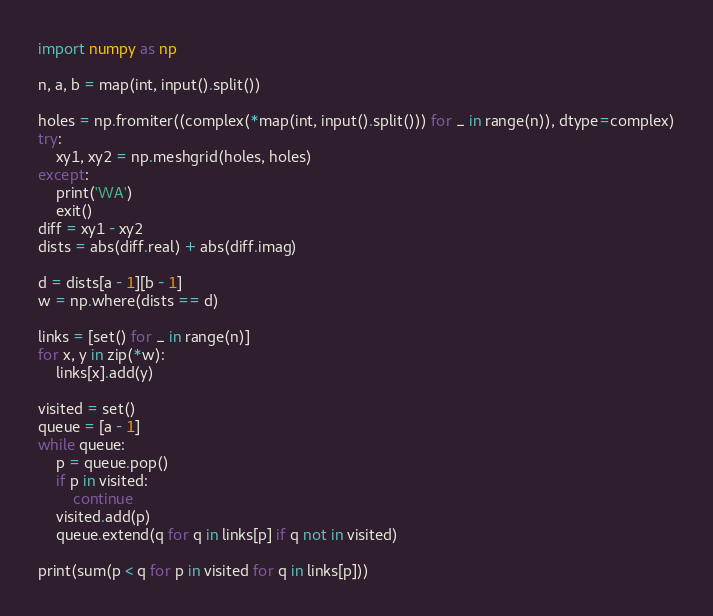Convert code to text. <code><loc_0><loc_0><loc_500><loc_500><_Python_>import numpy as np

n, a, b = map(int, input().split())

holes = np.fromiter((complex(*map(int, input().split())) for _ in range(n)), dtype=complex)
try:
    xy1, xy2 = np.meshgrid(holes, holes)
except:
    print('WA')
    exit()
diff = xy1 - xy2
dists = abs(diff.real) + abs(diff.imag)

d = dists[a - 1][b - 1]
w = np.where(dists == d)

links = [set() for _ in range(n)]
for x, y in zip(*w):
    links[x].add(y)

visited = set()
queue = [a - 1]
while queue:
    p = queue.pop()
    if p in visited:
        continue
    visited.add(p)
    queue.extend(q for q in links[p] if q not in visited)

print(sum(p < q for p in visited for q in links[p]))
</code> 